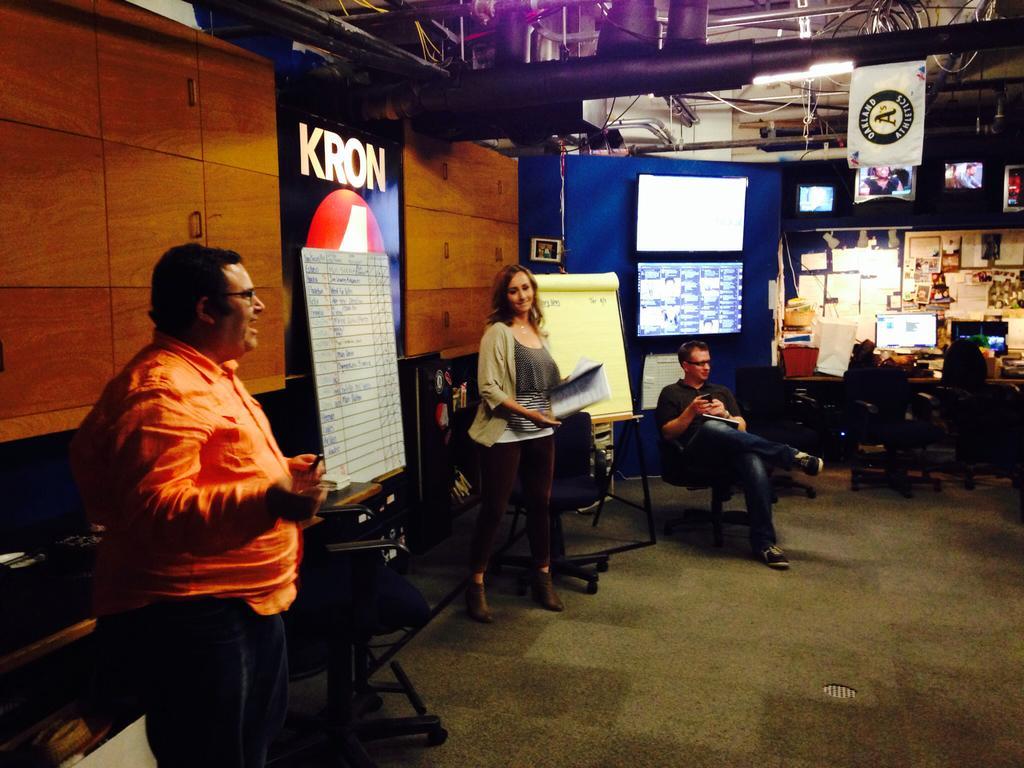Could you give a brief overview of what you see in this image? In this image I can see two persons standing, a person sitting on the chair, the brown colored wooden surface, few boards, few screens, the ceiling, few pipes, few lights to the ceiling, few papers attached to the boards and few other objects. 